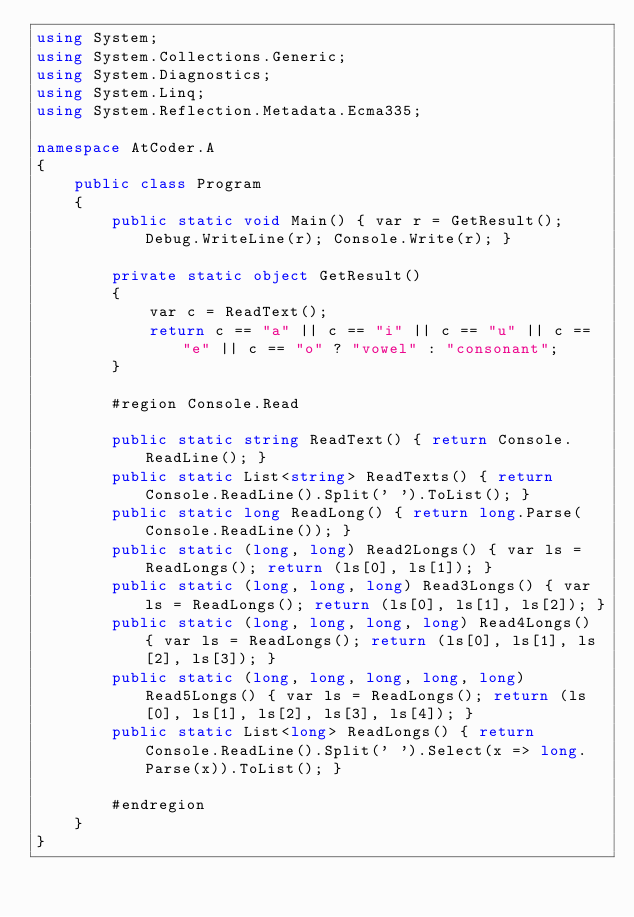<code> <loc_0><loc_0><loc_500><loc_500><_C#_>using System;
using System.Collections.Generic;
using System.Diagnostics;
using System.Linq;
using System.Reflection.Metadata.Ecma335;

namespace AtCoder.A
{
    public class Program
    {
        public static void Main() { var r = GetResult(); Debug.WriteLine(r); Console.Write(r); }

        private static object GetResult()
        {
            var c = ReadText();
            return c == "a" || c == "i" || c == "u" || c == "e" || c == "o" ? "vowel" : "consonant";
        }

        #region Console.Read

        public static string ReadText() { return Console.ReadLine(); }
        public static List<string> ReadTexts() { return Console.ReadLine().Split(' ').ToList(); }
        public static long ReadLong() { return long.Parse(Console.ReadLine()); }
        public static (long, long) Read2Longs() { var ls = ReadLongs(); return (ls[0], ls[1]); }
        public static (long, long, long) Read3Longs() { var ls = ReadLongs(); return (ls[0], ls[1], ls[2]); }
        public static (long, long, long, long) Read4Longs() { var ls = ReadLongs(); return (ls[0], ls[1], ls[2], ls[3]); }
        public static (long, long, long, long, long) Read5Longs() { var ls = ReadLongs(); return (ls[0], ls[1], ls[2], ls[3], ls[4]); }
        public static List<long> ReadLongs() { return Console.ReadLine().Split(' ').Select(x => long.Parse(x)).ToList(); }

        #endregion
    }
}
</code> 